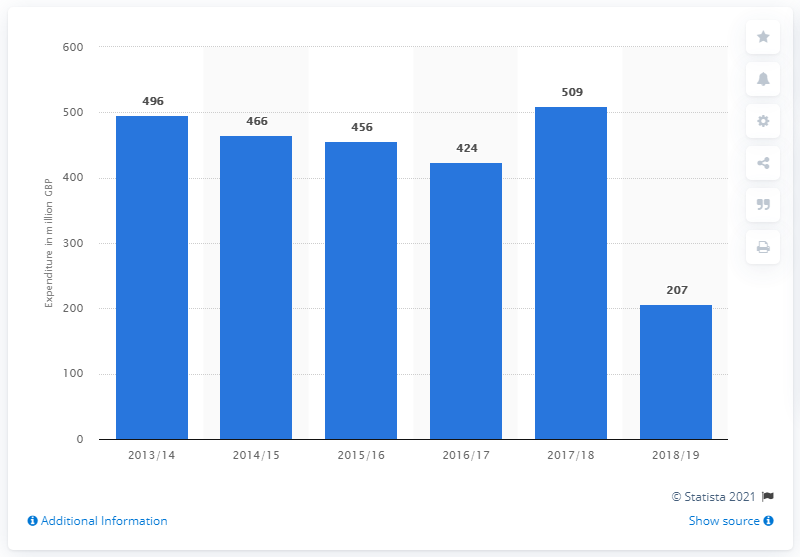Highlight a few significant elements in this photo. The amount spent on environmental protection research and development in the UK in 2017/18 was £509 million. The years 2017-2018 and 2018-2019 differ by one year, as the latter spans two consecutive years. The years 2018/19 were the lowest on the chart. 